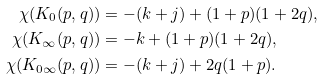<formula> <loc_0><loc_0><loc_500><loc_500>\chi ( K _ { 0 } ( p , q ) ) & = - ( k + j ) + ( 1 + p ) ( 1 + 2 q ) , \\ \chi ( K _ { \infty } ( p , q ) ) & = - k + ( 1 + p ) ( 1 + 2 q ) , \\ \chi ( K _ { 0 \infty } ( p , q ) ) & = - ( k + j ) + 2 q ( 1 + p ) .</formula> 